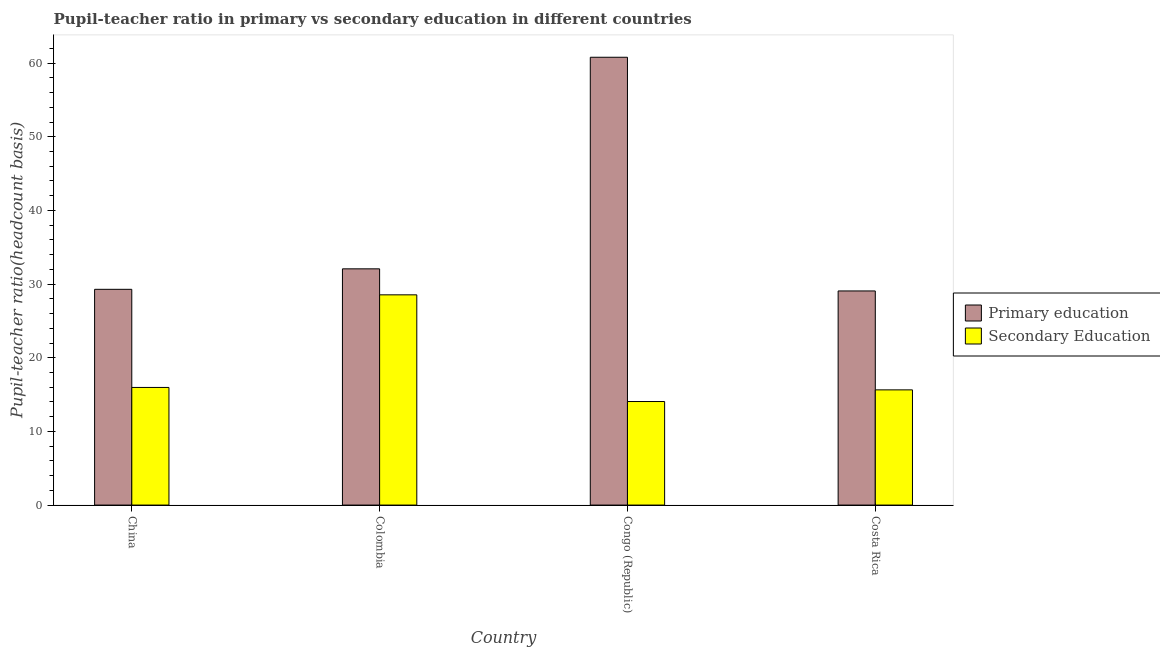How many groups of bars are there?
Provide a succinct answer. 4. How many bars are there on the 2nd tick from the left?
Make the answer very short. 2. How many bars are there on the 2nd tick from the right?
Your response must be concise. 2. In how many cases, is the number of bars for a given country not equal to the number of legend labels?
Your response must be concise. 0. What is the pupil teacher ratio on secondary education in Congo (Republic)?
Offer a very short reply. 14.06. Across all countries, what is the maximum pupil teacher ratio on secondary education?
Offer a very short reply. 28.54. Across all countries, what is the minimum pupil-teacher ratio in primary education?
Provide a short and direct response. 29.07. In which country was the pupil-teacher ratio in primary education maximum?
Ensure brevity in your answer.  Congo (Republic). In which country was the pupil teacher ratio on secondary education minimum?
Offer a terse response. Congo (Republic). What is the total pupil teacher ratio on secondary education in the graph?
Provide a short and direct response. 74.21. What is the difference between the pupil teacher ratio on secondary education in China and that in Colombia?
Your response must be concise. -12.57. What is the difference between the pupil teacher ratio on secondary education in Congo (Republic) and the pupil-teacher ratio in primary education in Colombia?
Your response must be concise. -18.01. What is the average pupil-teacher ratio in primary education per country?
Offer a very short reply. 37.81. What is the difference between the pupil teacher ratio on secondary education and pupil-teacher ratio in primary education in Colombia?
Keep it short and to the point. -3.53. What is the ratio of the pupil teacher ratio on secondary education in Colombia to that in Costa Rica?
Make the answer very short. 1.82. Is the difference between the pupil-teacher ratio in primary education in Colombia and Costa Rica greater than the difference between the pupil teacher ratio on secondary education in Colombia and Costa Rica?
Your answer should be compact. No. What is the difference between the highest and the second highest pupil-teacher ratio in primary education?
Your answer should be very brief. 28.72. What is the difference between the highest and the lowest pupil teacher ratio on secondary education?
Your answer should be very brief. 14.48. What does the 2nd bar from the left in Costa Rica represents?
Keep it short and to the point. Secondary Education. What does the 1st bar from the right in Colombia represents?
Ensure brevity in your answer.  Secondary Education. Are all the bars in the graph horizontal?
Your response must be concise. No. Are the values on the major ticks of Y-axis written in scientific E-notation?
Your response must be concise. No. Does the graph contain any zero values?
Provide a succinct answer. No. Does the graph contain grids?
Your answer should be compact. No. Where does the legend appear in the graph?
Give a very brief answer. Center right. How many legend labels are there?
Your answer should be compact. 2. What is the title of the graph?
Ensure brevity in your answer.  Pupil-teacher ratio in primary vs secondary education in different countries. Does "Nonresident" appear as one of the legend labels in the graph?
Your answer should be very brief. No. What is the label or title of the Y-axis?
Your answer should be compact. Pupil-teacher ratio(headcount basis). What is the Pupil-teacher ratio(headcount basis) of Primary education in China?
Keep it short and to the point. 29.29. What is the Pupil-teacher ratio(headcount basis) in Secondary Education in China?
Make the answer very short. 15.97. What is the Pupil-teacher ratio(headcount basis) of Primary education in Colombia?
Your response must be concise. 32.07. What is the Pupil-teacher ratio(headcount basis) of Secondary Education in Colombia?
Provide a short and direct response. 28.54. What is the Pupil-teacher ratio(headcount basis) of Primary education in Congo (Republic)?
Provide a succinct answer. 60.79. What is the Pupil-teacher ratio(headcount basis) in Secondary Education in Congo (Republic)?
Offer a very short reply. 14.06. What is the Pupil-teacher ratio(headcount basis) of Primary education in Costa Rica?
Offer a very short reply. 29.07. What is the Pupil-teacher ratio(headcount basis) in Secondary Education in Costa Rica?
Offer a very short reply. 15.64. Across all countries, what is the maximum Pupil-teacher ratio(headcount basis) in Primary education?
Ensure brevity in your answer.  60.79. Across all countries, what is the maximum Pupil-teacher ratio(headcount basis) of Secondary Education?
Your response must be concise. 28.54. Across all countries, what is the minimum Pupil-teacher ratio(headcount basis) in Primary education?
Your answer should be very brief. 29.07. Across all countries, what is the minimum Pupil-teacher ratio(headcount basis) in Secondary Education?
Give a very brief answer. 14.06. What is the total Pupil-teacher ratio(headcount basis) of Primary education in the graph?
Your answer should be compact. 151.23. What is the total Pupil-teacher ratio(headcount basis) of Secondary Education in the graph?
Keep it short and to the point. 74.21. What is the difference between the Pupil-teacher ratio(headcount basis) in Primary education in China and that in Colombia?
Give a very brief answer. -2.78. What is the difference between the Pupil-teacher ratio(headcount basis) in Secondary Education in China and that in Colombia?
Give a very brief answer. -12.57. What is the difference between the Pupil-teacher ratio(headcount basis) of Primary education in China and that in Congo (Republic)?
Provide a short and direct response. -31.5. What is the difference between the Pupil-teacher ratio(headcount basis) of Secondary Education in China and that in Congo (Republic)?
Ensure brevity in your answer.  1.91. What is the difference between the Pupil-teacher ratio(headcount basis) of Primary education in China and that in Costa Rica?
Provide a short and direct response. 0.22. What is the difference between the Pupil-teacher ratio(headcount basis) in Secondary Education in China and that in Costa Rica?
Make the answer very short. 0.33. What is the difference between the Pupil-teacher ratio(headcount basis) in Primary education in Colombia and that in Congo (Republic)?
Make the answer very short. -28.72. What is the difference between the Pupil-teacher ratio(headcount basis) of Secondary Education in Colombia and that in Congo (Republic)?
Make the answer very short. 14.48. What is the difference between the Pupil-teacher ratio(headcount basis) in Primary education in Colombia and that in Costa Rica?
Offer a terse response. 3. What is the difference between the Pupil-teacher ratio(headcount basis) of Secondary Education in Colombia and that in Costa Rica?
Offer a very short reply. 12.9. What is the difference between the Pupil-teacher ratio(headcount basis) of Primary education in Congo (Republic) and that in Costa Rica?
Offer a very short reply. 31.73. What is the difference between the Pupil-teacher ratio(headcount basis) in Secondary Education in Congo (Republic) and that in Costa Rica?
Your answer should be compact. -1.58. What is the difference between the Pupil-teacher ratio(headcount basis) in Primary education in China and the Pupil-teacher ratio(headcount basis) in Secondary Education in Colombia?
Provide a succinct answer. 0.75. What is the difference between the Pupil-teacher ratio(headcount basis) of Primary education in China and the Pupil-teacher ratio(headcount basis) of Secondary Education in Congo (Republic)?
Provide a succinct answer. 15.23. What is the difference between the Pupil-teacher ratio(headcount basis) in Primary education in China and the Pupil-teacher ratio(headcount basis) in Secondary Education in Costa Rica?
Provide a succinct answer. 13.65. What is the difference between the Pupil-teacher ratio(headcount basis) of Primary education in Colombia and the Pupil-teacher ratio(headcount basis) of Secondary Education in Congo (Republic)?
Provide a short and direct response. 18.01. What is the difference between the Pupil-teacher ratio(headcount basis) in Primary education in Colombia and the Pupil-teacher ratio(headcount basis) in Secondary Education in Costa Rica?
Your answer should be compact. 16.43. What is the difference between the Pupil-teacher ratio(headcount basis) of Primary education in Congo (Republic) and the Pupil-teacher ratio(headcount basis) of Secondary Education in Costa Rica?
Ensure brevity in your answer.  45.15. What is the average Pupil-teacher ratio(headcount basis) in Primary education per country?
Your answer should be very brief. 37.81. What is the average Pupil-teacher ratio(headcount basis) of Secondary Education per country?
Make the answer very short. 18.55. What is the difference between the Pupil-teacher ratio(headcount basis) in Primary education and Pupil-teacher ratio(headcount basis) in Secondary Education in China?
Give a very brief answer. 13.32. What is the difference between the Pupil-teacher ratio(headcount basis) of Primary education and Pupil-teacher ratio(headcount basis) of Secondary Education in Colombia?
Give a very brief answer. 3.53. What is the difference between the Pupil-teacher ratio(headcount basis) of Primary education and Pupil-teacher ratio(headcount basis) of Secondary Education in Congo (Republic)?
Provide a short and direct response. 46.74. What is the difference between the Pupil-teacher ratio(headcount basis) of Primary education and Pupil-teacher ratio(headcount basis) of Secondary Education in Costa Rica?
Provide a succinct answer. 13.43. What is the ratio of the Pupil-teacher ratio(headcount basis) in Primary education in China to that in Colombia?
Ensure brevity in your answer.  0.91. What is the ratio of the Pupil-teacher ratio(headcount basis) of Secondary Education in China to that in Colombia?
Provide a succinct answer. 0.56. What is the ratio of the Pupil-teacher ratio(headcount basis) of Primary education in China to that in Congo (Republic)?
Your response must be concise. 0.48. What is the ratio of the Pupil-teacher ratio(headcount basis) in Secondary Education in China to that in Congo (Republic)?
Your response must be concise. 1.14. What is the ratio of the Pupil-teacher ratio(headcount basis) of Primary education in China to that in Costa Rica?
Offer a terse response. 1.01. What is the ratio of the Pupil-teacher ratio(headcount basis) of Primary education in Colombia to that in Congo (Republic)?
Your response must be concise. 0.53. What is the ratio of the Pupil-teacher ratio(headcount basis) in Secondary Education in Colombia to that in Congo (Republic)?
Offer a terse response. 2.03. What is the ratio of the Pupil-teacher ratio(headcount basis) of Primary education in Colombia to that in Costa Rica?
Provide a short and direct response. 1.1. What is the ratio of the Pupil-teacher ratio(headcount basis) of Secondary Education in Colombia to that in Costa Rica?
Make the answer very short. 1.82. What is the ratio of the Pupil-teacher ratio(headcount basis) of Primary education in Congo (Republic) to that in Costa Rica?
Make the answer very short. 2.09. What is the ratio of the Pupil-teacher ratio(headcount basis) of Secondary Education in Congo (Republic) to that in Costa Rica?
Keep it short and to the point. 0.9. What is the difference between the highest and the second highest Pupil-teacher ratio(headcount basis) of Primary education?
Your answer should be very brief. 28.72. What is the difference between the highest and the second highest Pupil-teacher ratio(headcount basis) in Secondary Education?
Your response must be concise. 12.57. What is the difference between the highest and the lowest Pupil-teacher ratio(headcount basis) of Primary education?
Provide a short and direct response. 31.73. What is the difference between the highest and the lowest Pupil-teacher ratio(headcount basis) in Secondary Education?
Your answer should be very brief. 14.48. 